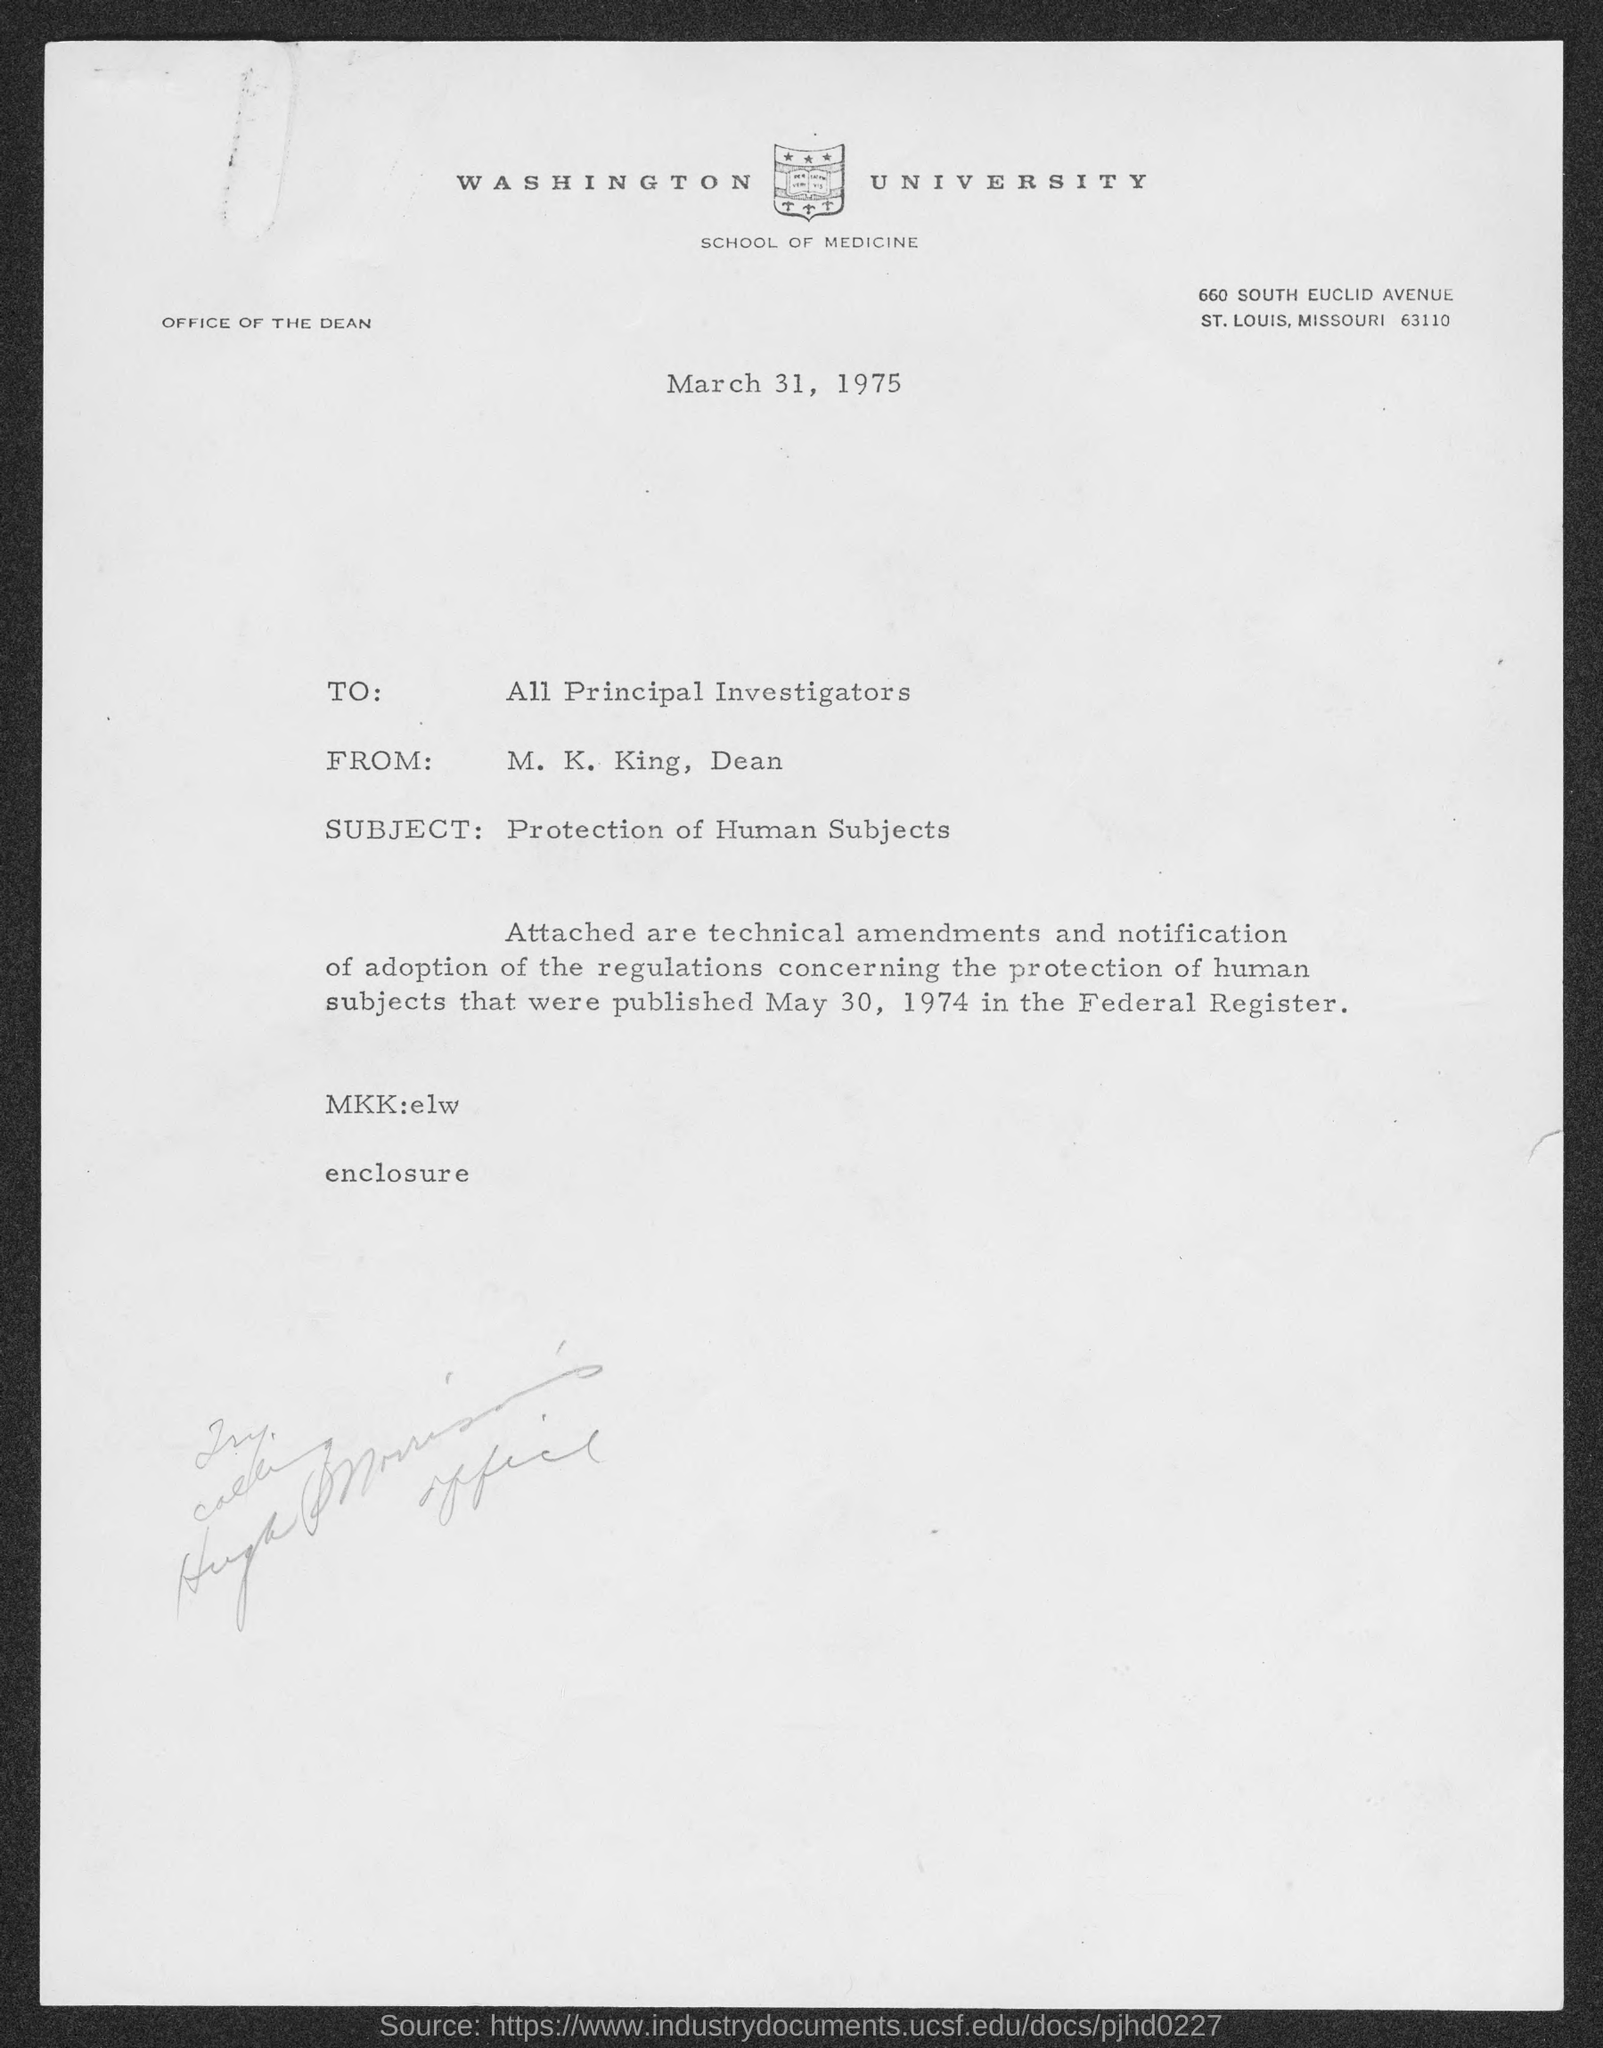Which University is mentioned in the letter head?
Give a very brief answer. WASHINGTON UNIVERSITY. What is the date mentioned in this letter?
Ensure brevity in your answer.  March 31, 1975. Who is the sender of this letter?
Offer a terse response. M. K. King, Dean. Who is the receiver of this letter?
Make the answer very short. All Principal Investigators. What is the subject of this letter?
Offer a terse response. Protection of Human Subjects. 